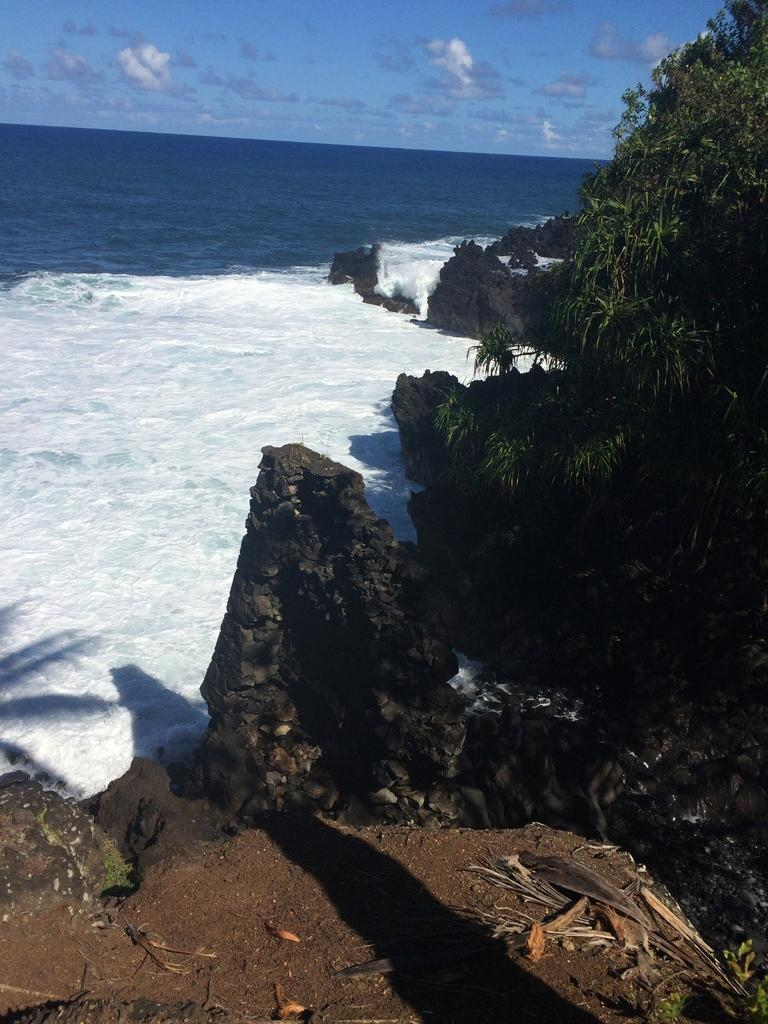What is the main element present in the image? There is water in the image. What can be seen on the right side of the image? There are rocks to the right of the image. What is growing on the rocks? There are plants on the rocks. What is visible at the top of the image? The sky is visible at the top of the image. What type of bike is being used to process food in the image? There is no bike or food processing activity present in the image. What type of oven is visible in the image? There is no oven present in the image. 